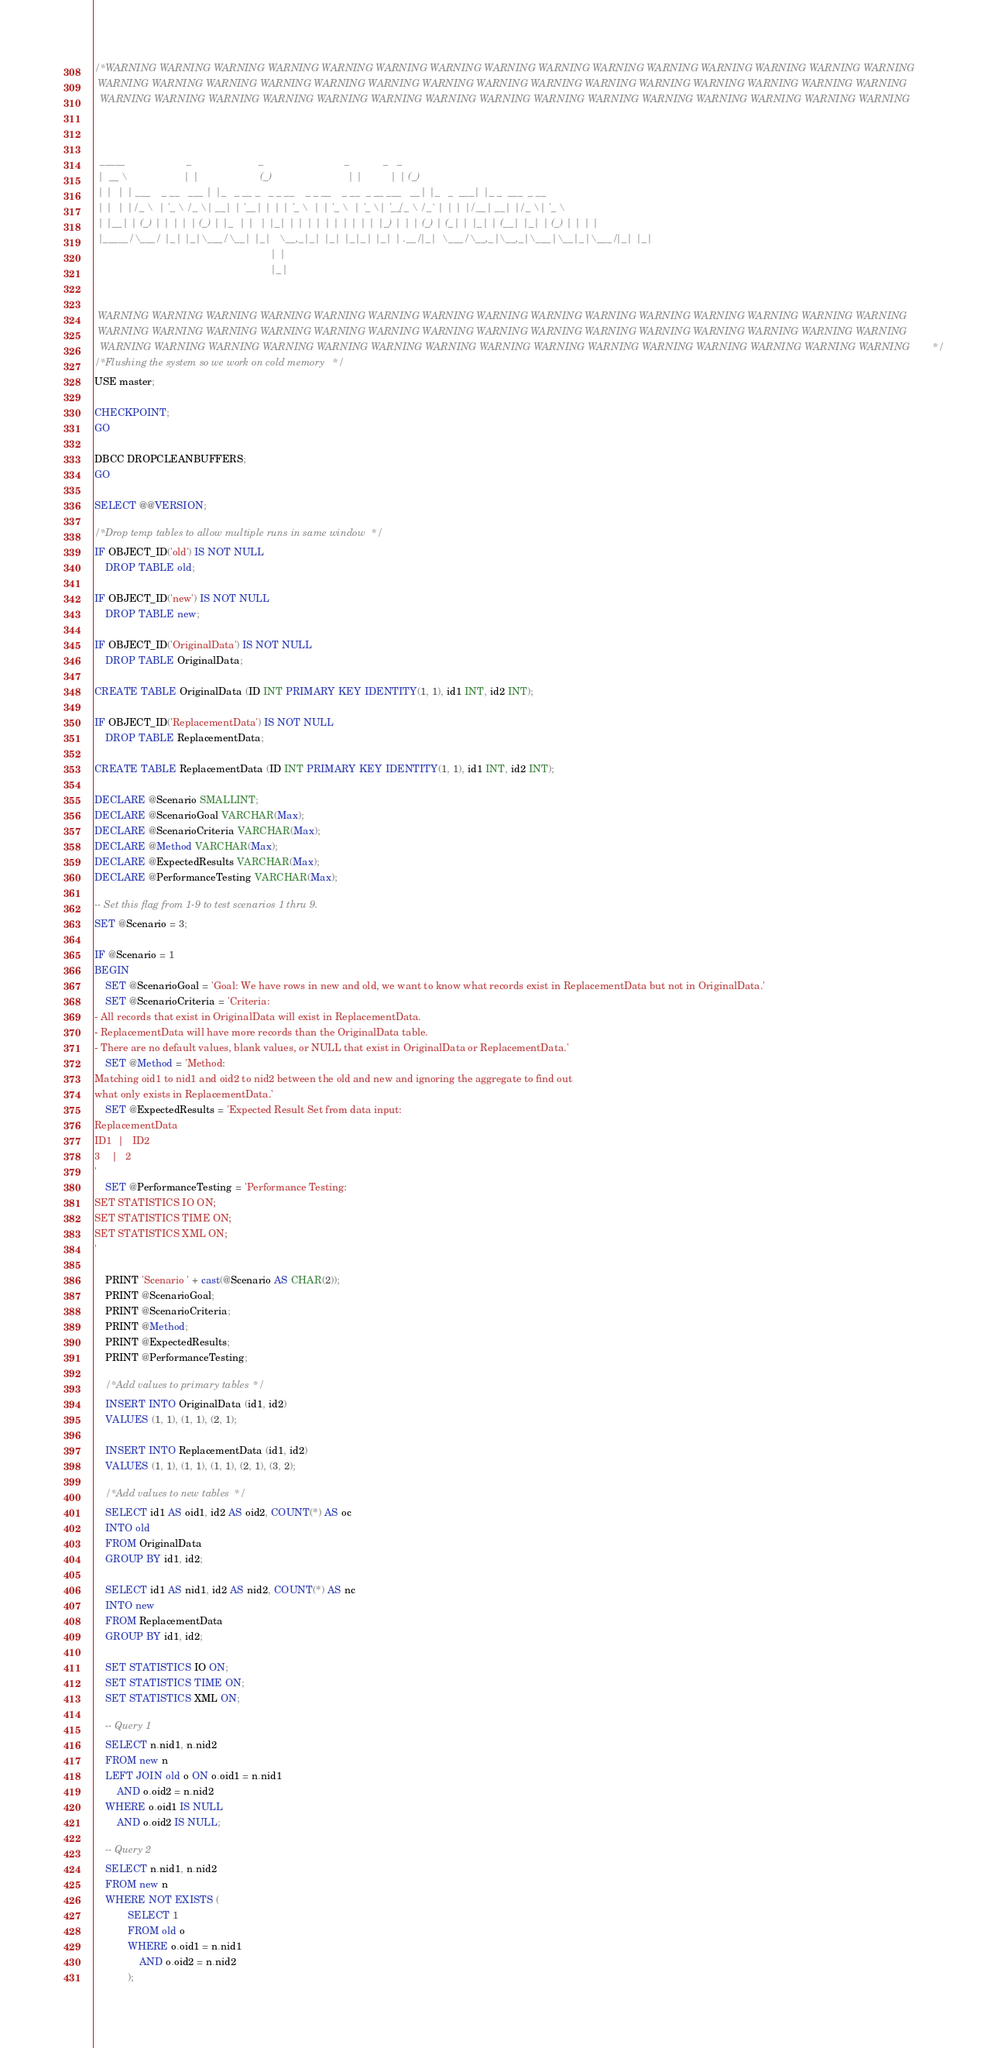Convert code to text. <code><loc_0><loc_0><loc_500><loc_500><_SQL_>/* WARNING WARNING WARNING WARNING WARNING WARNING WARNING WARNING WARNING WARNING WARNING WARNING WARNING WARNING WARNING
 WARNING WARNING WARNING WARNING WARNING WARNING WARNING WARNING WARNING WARNING WARNING WARNING WARNING WARNING WARNING
  WARNING WARNING WARNING WARNING WARNING WARNING WARNING WARNING WARNING WARNING WARNING WARNING WARNING WARNING WARNING

  

  _____                      _                        _                             _            _   _             
 |  __ \                    | |                      (_)                           | |          | | (_)            
 | |  | | ___    _ __   ___ | |_   _ __ _   _ _ __    _ _ __    _ __  _ __ ___   __| |_   _  ___| |_ _  ___  _ __  
 | |  | |/ _ \  | '_ \ / _ \| __| | '__| | | | '_ \  | | '_ \  | '_ \| '__/ _ \ / _` | | | |/ __| __| |/ _ \| '_ \ 
 | |__| | (_) | | | | | (_) | |_  | |  | |_| | | | | | | | | | | |_) | | | (_) | (_| | |_| | (__| |_| | (_) | | | |
 |_____/ \___/  |_| |_|\___/ \__| |_|   \__,_|_| |_| |_|_| |_| | .__/|_|  \___/ \__,_|\__,_|\___|\__|_|\___/|_| |_|
                                                               | |                                                 
                                                               |_|                                                 


 WARNING WARNING WARNING WARNING WARNING WARNING WARNING WARNING WARNING WARNING WARNING WARNING WARNING WARNING WARNING
 WARNING WARNING WARNING WARNING WARNING WARNING WARNING WARNING WARNING WARNING WARNING WARNING WARNING WARNING WARNING
  WARNING WARNING WARNING WARNING WARNING WARNING WARNING WARNING WARNING WARNING WARNING WARNING WARNING WARNING WARNING */
/* Flushing the system so we work on cold memory */
USE master;

CHECKPOINT;
GO

DBCC DROPCLEANBUFFERS;
GO

SELECT @@VERSION;

/* Drop temp tables to allow multiple runs in same window */
IF OBJECT_ID('old') IS NOT NULL
	DROP TABLE old;

IF OBJECT_ID('new') IS NOT NULL
	DROP TABLE new;

IF OBJECT_ID('OriginalData') IS NOT NULL
	DROP TABLE OriginalData;

CREATE TABLE OriginalData (ID INT PRIMARY KEY IDENTITY(1, 1), id1 INT, id2 INT);

IF OBJECT_ID('ReplacementData') IS NOT NULL
	DROP TABLE ReplacementData;

CREATE TABLE ReplacementData (ID INT PRIMARY KEY IDENTITY(1, 1), id1 INT, id2 INT);

DECLARE @Scenario SMALLINT;
DECLARE @ScenarioGoal VARCHAR(Max);
DECLARE @ScenarioCriteria VARCHAR(Max);
DECLARE @Method VARCHAR(Max);
DECLARE @ExpectedResults VARCHAR(Max);
DECLARE @PerformanceTesting VARCHAR(Max);

-- Set this flag from 1-9 to test scenarios 1 thru 9.
SET @Scenario = 3;

IF @Scenario = 1
BEGIN
	SET @ScenarioGoal = 'Goal: We have rows in new and old, we want to know what records exist in ReplacementData but not in OriginalData.'
	SET @ScenarioCriteria = 'Criteria:
- All records that exist in OriginalData will exist in ReplacementData.
- ReplacementData will have more records than the OriginalData table.
- There are no default values, blank values, or NULL that exist in OriginalData or ReplacementData.'
	SET @Method = 'Method: 
Matching oid1 to nid1 and oid2 to nid2 between the old and new and ignoring the aggregate to find out
what only exists in ReplacementData.'
	SET @ExpectedResults = 'Expected Result Set from data input:
ReplacementData
ID1	 |	 ID2
3	 |	 2
'
	SET @PerformanceTesting = 'Performance Testing:
SET STATISTICS IO ON;
SET STATISTICS TIME ON;
SET STATISTICS XML ON;
'

	PRINT 'Scenario ' + cast(@Scenario AS CHAR(2));
	PRINT @ScenarioGoal;
	PRINT @ScenarioCriteria;
	PRINT @Method;
	PRINT @ExpectedResults;
	PRINT @PerformanceTesting;

	/* Add values to primary tables */
	INSERT INTO OriginalData (id1, id2)
	VALUES (1, 1), (1, 1), (2, 1);

	INSERT INTO ReplacementData (id1, id2)
	VALUES (1, 1), (1, 1), (1, 1), (2, 1), (3, 2);

	/* Add values to new tables */
	SELECT id1 AS oid1, id2 AS oid2, COUNT(*) AS oc
	INTO old
	FROM OriginalData
	GROUP BY id1, id2;

	SELECT id1 AS nid1, id2 AS nid2, COUNT(*) AS nc
	INTO new
	FROM ReplacementData
	GROUP BY id1, id2;

	SET STATISTICS IO ON;
	SET STATISTICS TIME ON;
	SET STATISTICS XML ON;

	-- Query 1
	SELECT n.nid1, n.nid2
	FROM new n
	LEFT JOIN old o ON o.oid1 = n.nid1
		AND o.oid2 = n.nid2
	WHERE o.oid1 IS NULL
		AND o.oid2 IS NULL;

	-- Query 2
	SELECT n.nid1, n.nid2
	FROM new n
	WHERE NOT EXISTS (
			SELECT 1
			FROM old o
			WHERE o.oid1 = n.nid1
				AND o.oid2 = n.nid2
			);
</code> 